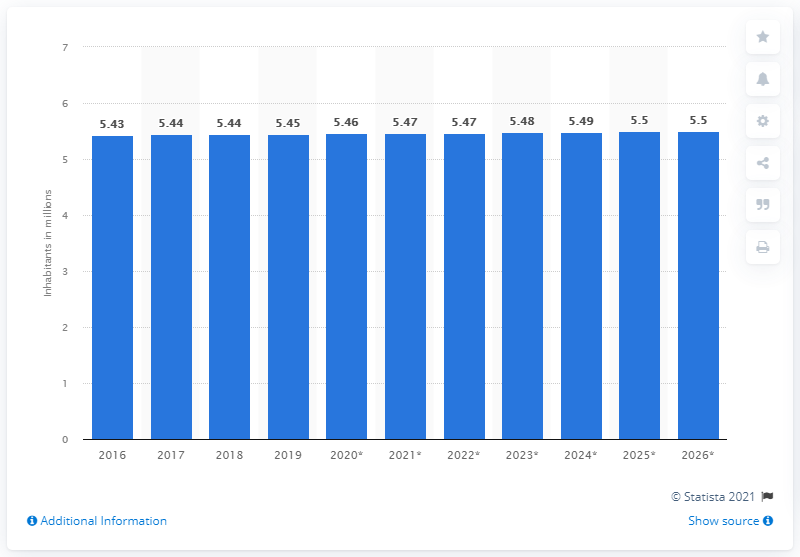Indicate a few pertinent items in this graphic. In 2019, Slovakia's population was 5.5 million. 